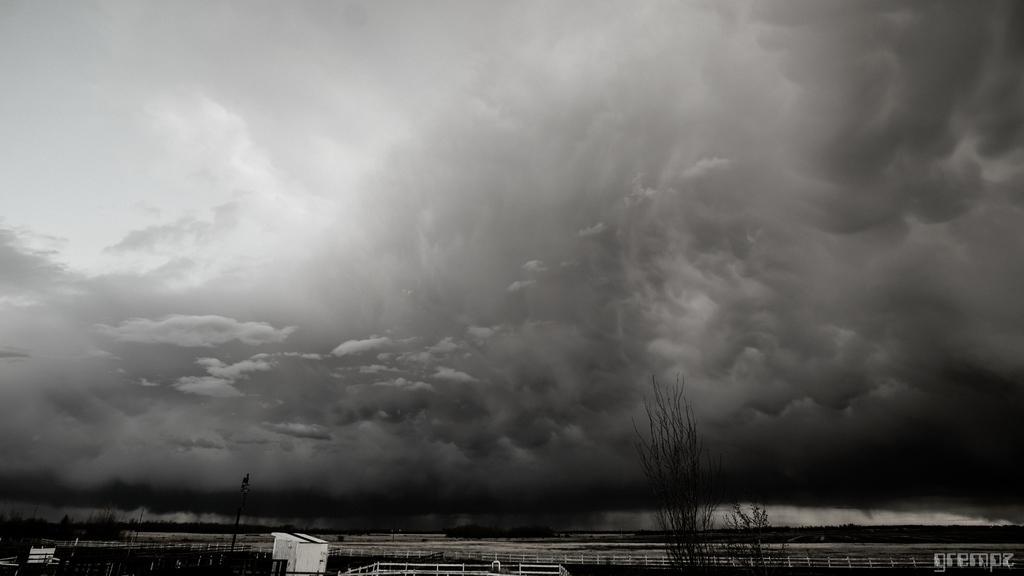Can you describe this image briefly? In this image at the bottom there are some trees and a walkway and some houses and poles, and at the top of the image there is sky. 